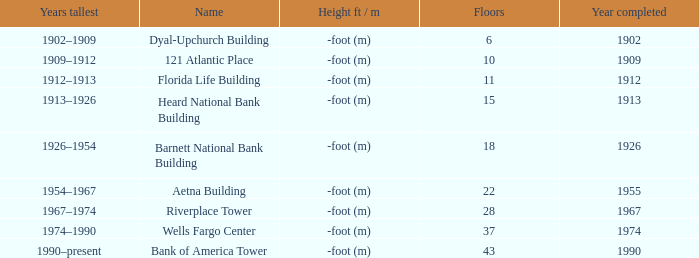Would you mind parsing the complete table? {'header': ['Years tallest', 'Name', 'Height ft / m', 'Floors', 'Year completed'], 'rows': [['1902–1909', 'Dyal-Upchurch Building', '-foot (m)', '6', '1902'], ['1909–1912', '121 Atlantic Place', '-foot (m)', '10', '1909'], ['1912–1913', 'Florida Life Building', '-foot (m)', '11', '1912'], ['1913–1926', 'Heard National Bank Building', '-foot (m)', '15', '1913'], ['1926–1954', 'Barnett National Bank Building', '-foot (m)', '18', '1926'], ['1954–1967', 'Aetna Building', '-foot (m)', '22', '1955'], ['1967–1974', 'Riverplace Tower', '-foot (m)', '28', '1967'], ['1974–1990', 'Wells Fargo Center', '-foot (m)', '37', '1974'], ['1990–present', 'Bank of America Tower', '-foot (m)', '43', '1990']]} What was the name of the building with 10 floors? 121 Atlantic Place. 